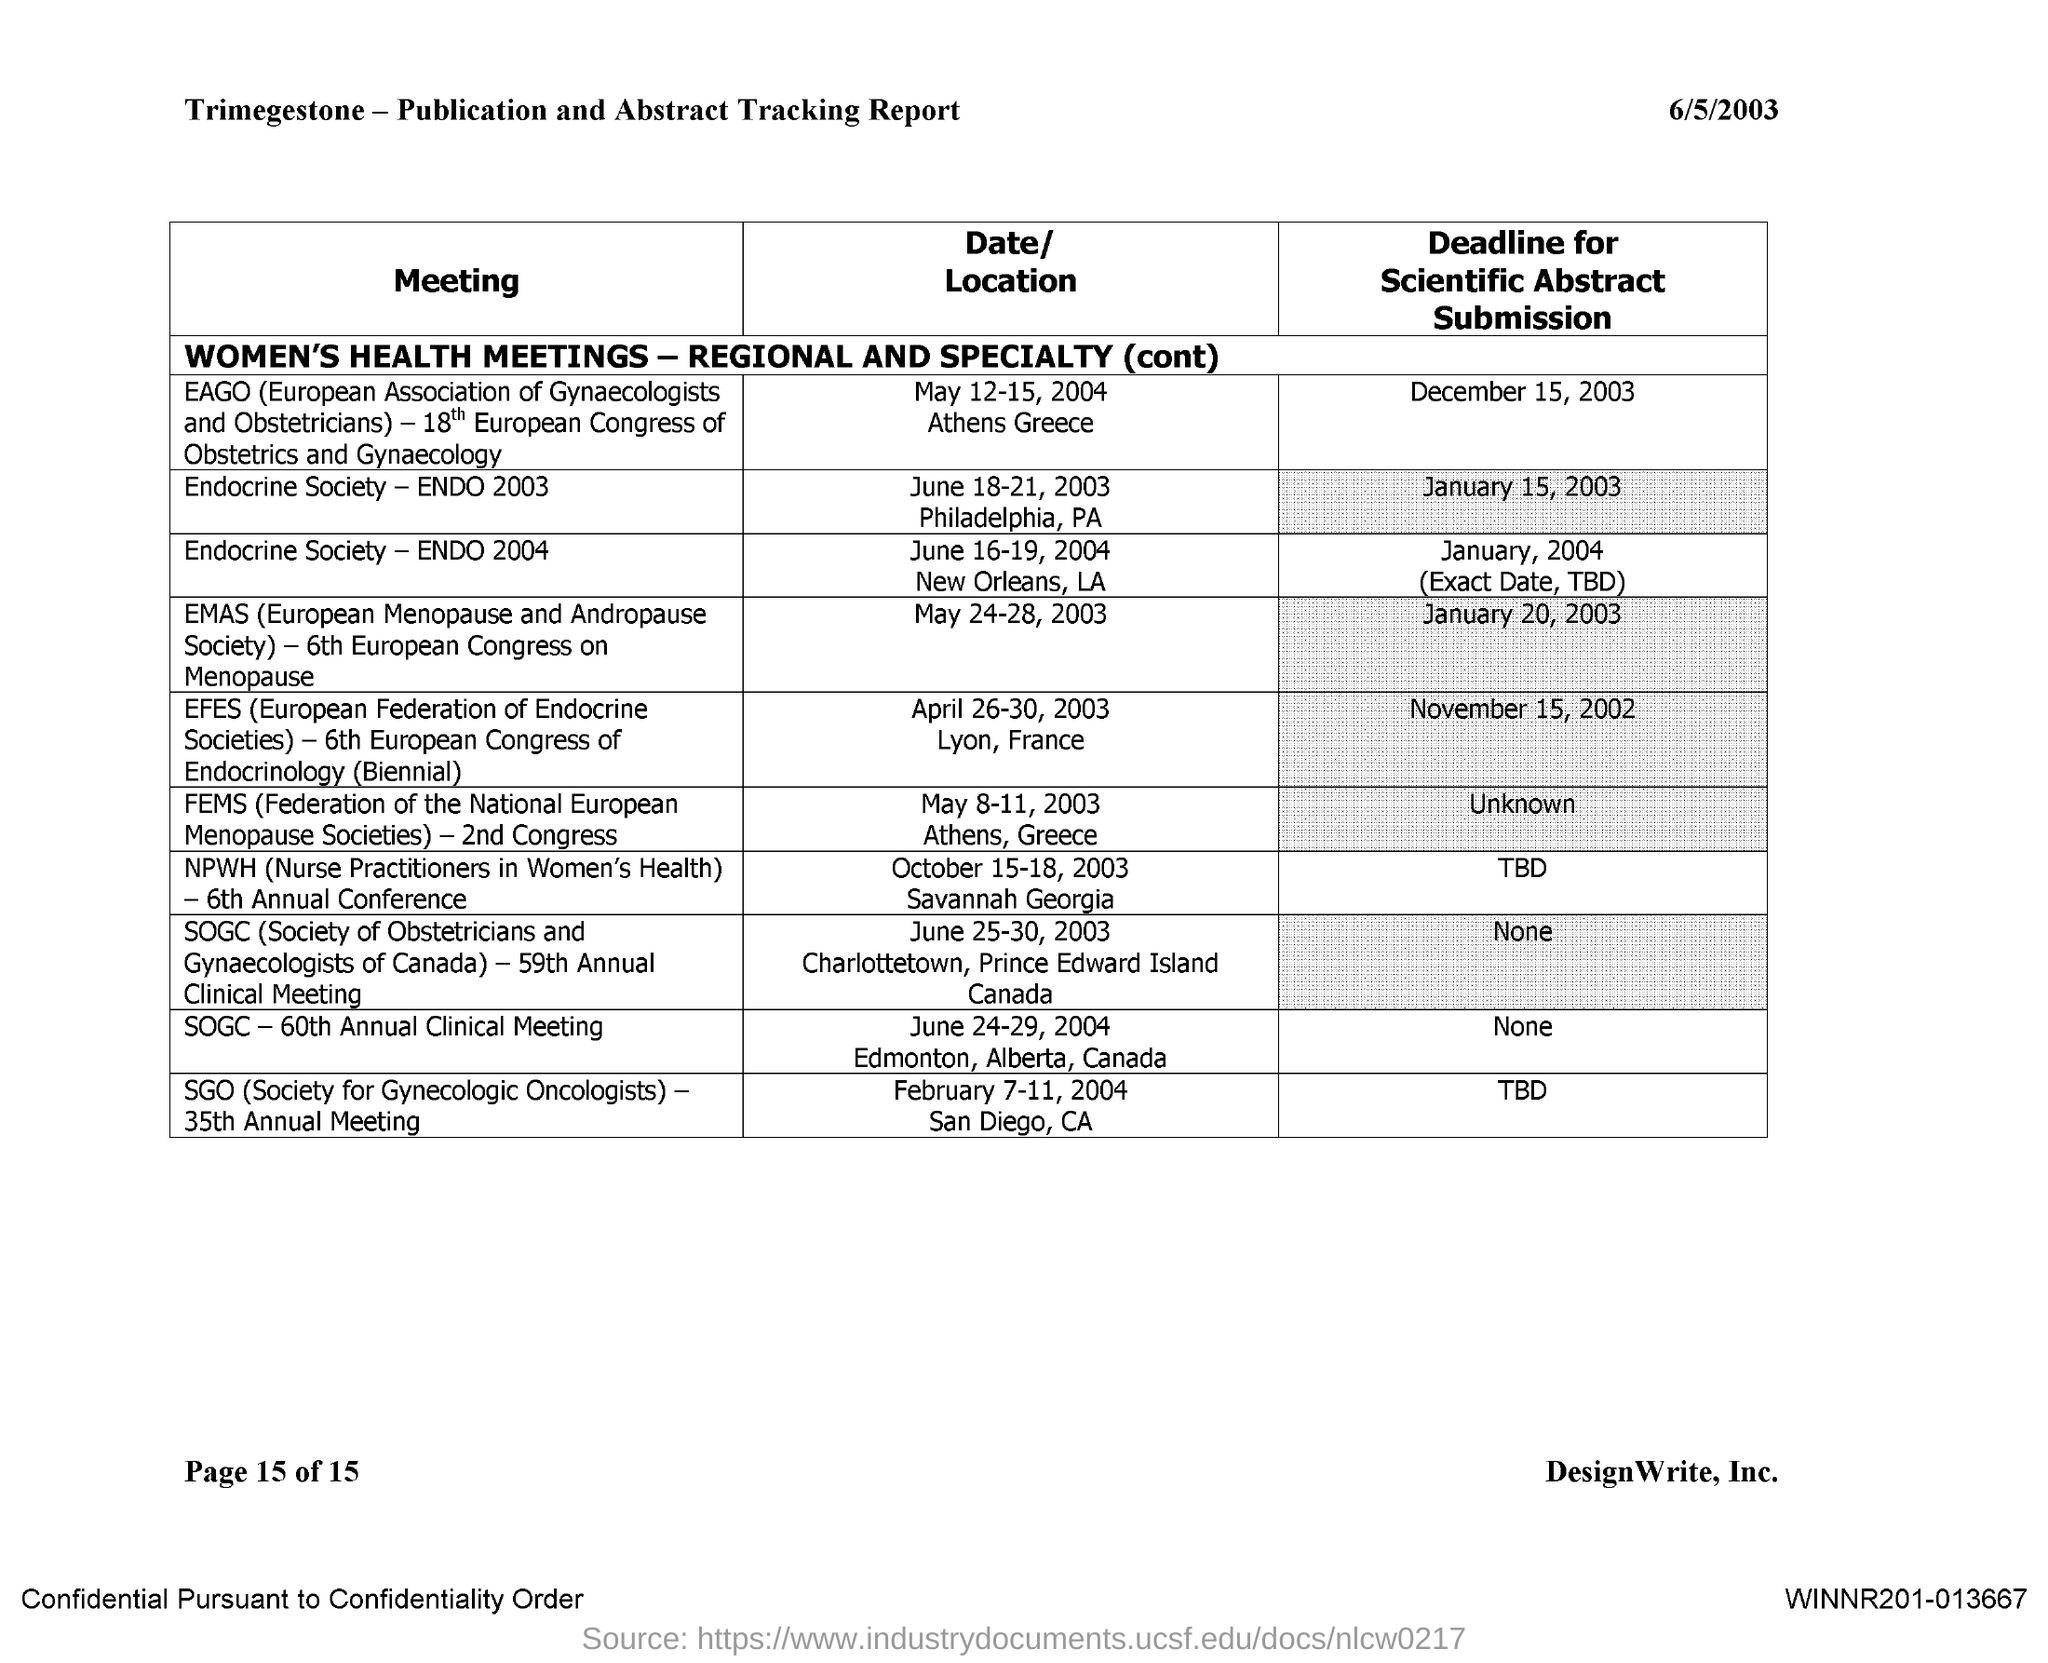Identify some key points in this picture. The heading for the first column is 'Meeting.' The deadline for scientific abstract submission for the Endocrine Society conference in 2003 was January 15, 2003. The SGO 35th annual meeting will take place on February 7-11, 2004, in San Diego, California. The date mentioned on the report is 6/5/2003. 